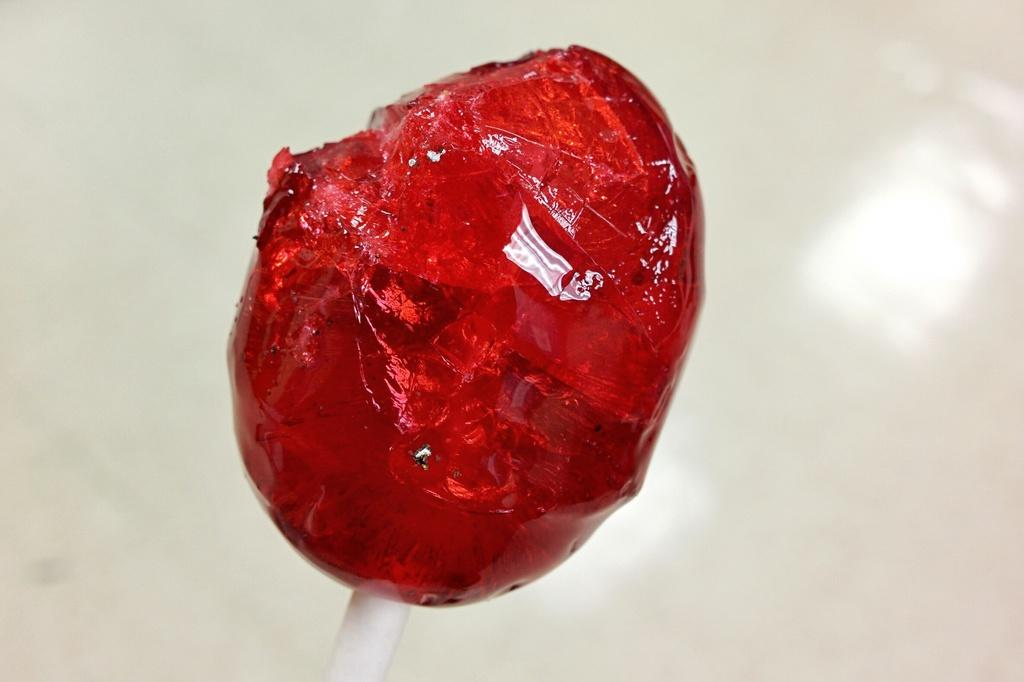What is the main object in the image? There is a lollipop in the image. What color is the background of the image? The background of the image is white. How many dimes are stacked on the lollipop in the image? There are no dimes present in the image; it only features a lollipop. What type of finger can be seen holding the lollipop in the image? There is no finger holding the lollipop in the image; it is not depicted as being held by anyone. 